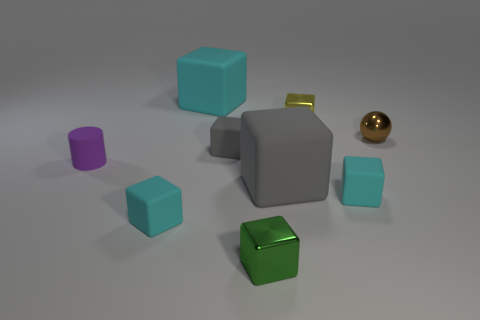The large rubber object left of the green metal object in front of the purple matte thing is what color?
Your response must be concise. Cyan. There is a tiny metal thing that is in front of the tiny brown metallic thing; is it the same shape as the big cyan rubber thing?
Keep it short and to the point. Yes. How many small rubber objects are behind the big gray matte cube and on the right side of the purple object?
Keep it short and to the point. 1. There is a big matte thing on the left side of the big cube that is in front of the big cube that is on the left side of the tiny green cube; what is its color?
Provide a short and direct response. Cyan. What number of tiny yellow shiny cubes are in front of the tiny cyan matte cube on the left side of the big cyan thing?
Make the answer very short. 0. What number of other objects are there of the same shape as the purple matte object?
Make the answer very short. 0. What number of objects are either large gray matte spheres or metal objects to the right of the yellow metal cube?
Give a very brief answer. 1. Is the number of small brown shiny spheres to the left of the small metallic sphere greater than the number of tiny brown metal objects on the left side of the small yellow thing?
Your answer should be compact. No. What is the shape of the brown shiny object that is behind the small purple cylinder to the left of the tiny green object that is to the left of the small brown sphere?
Keep it short and to the point. Sphere. There is a cyan object to the right of the metal block behind the small shiny ball; what shape is it?
Give a very brief answer. Cube. 